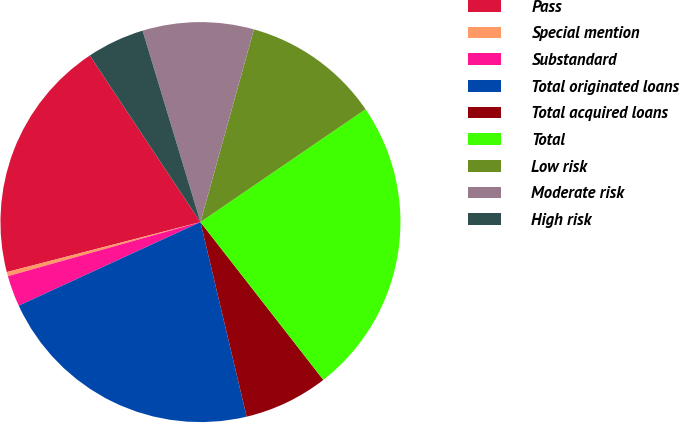Convert chart. <chart><loc_0><loc_0><loc_500><loc_500><pie_chart><fcel>Pass<fcel>Special mention<fcel>Substandard<fcel>Total originated loans<fcel>Total acquired loans<fcel>Total<fcel>Low risk<fcel>Moderate risk<fcel>High risk<nl><fcel>19.69%<fcel>0.34%<fcel>2.5%<fcel>21.85%<fcel>6.82%<fcel>24.01%<fcel>11.15%<fcel>8.98%<fcel>4.66%<nl></chart> 